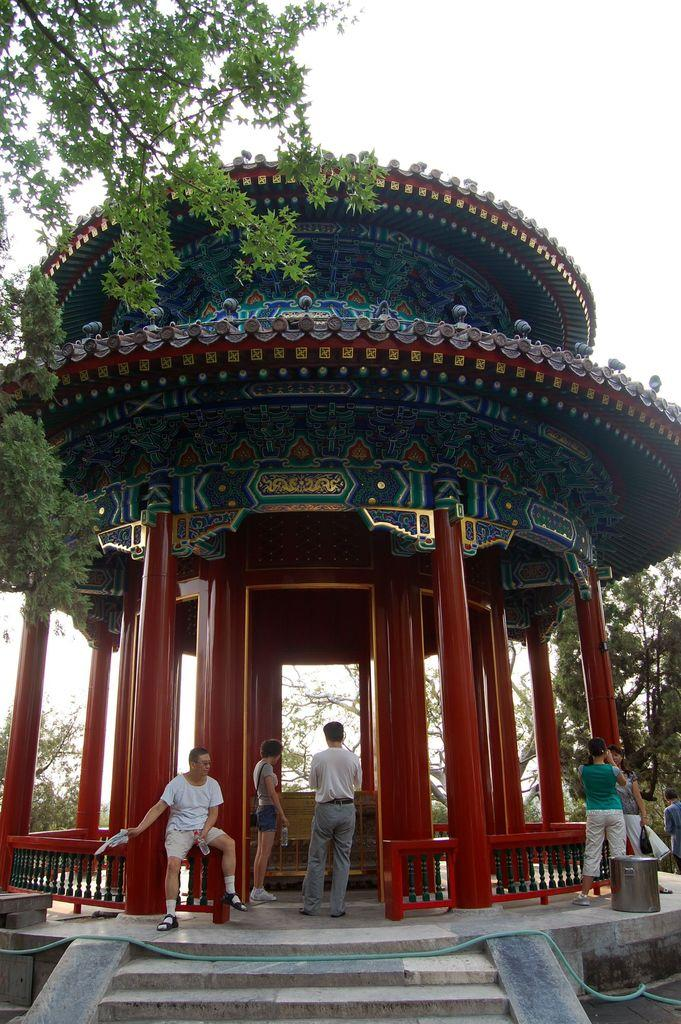How many people are in the image? There are people in the image, but the exact number is not specified. What are the people in the image doing? One person is sitting, while others are standing. What architectural feature is present in the image? There are stairs in the image. What color are the pillars in the image? The pillars in the image are red-colored. What type of vegetation is visible in the image? There are trees in the image. What type of design elements can be seen in the image? There are designs visible in the image. What type of river can be seen flowing through the image? There is no river present in the image. What type of system is being used by the people in the image? The facts provided do not mention any system being used by the people in the image. 